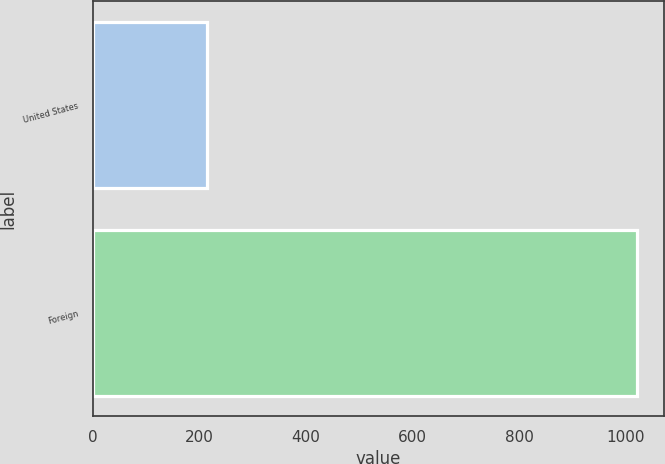<chart> <loc_0><loc_0><loc_500><loc_500><bar_chart><fcel>United States<fcel>Foreign<nl><fcel>214<fcel>1022<nl></chart> 